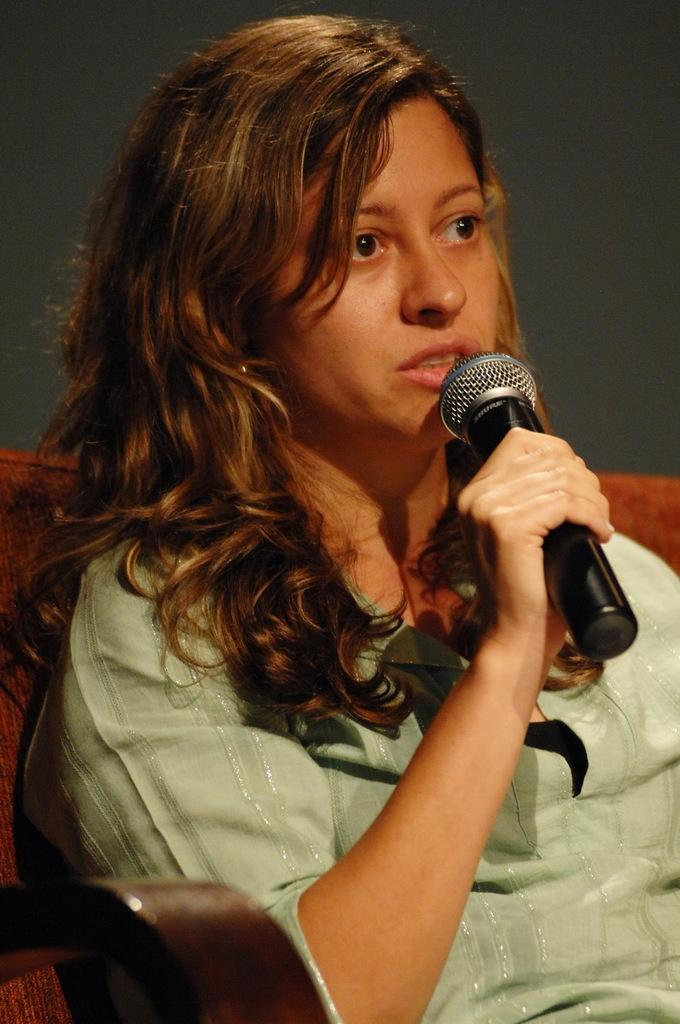Who or what is the main subject in the image? There is a person in the image. What is the person wearing? The person is wearing a cream-colored shirt. What is the person holding in the image? The person is holding a microphone. What color is the background of the image? The background of the image is gray. What type of pie is being served on a silver platter in the image? There is no pie or silver platter present in the image; it features a person holding a microphone against a gray background. 